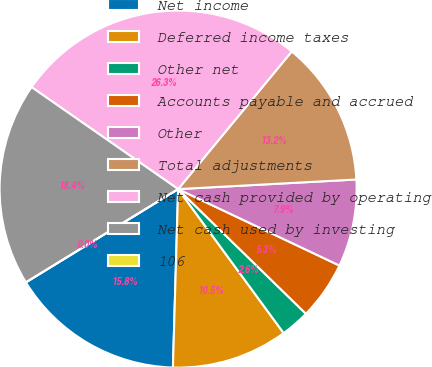Convert chart to OTSL. <chart><loc_0><loc_0><loc_500><loc_500><pie_chart><fcel>Net income<fcel>Deferred income taxes<fcel>Other net<fcel>Accounts payable and accrued<fcel>Other<fcel>Total adjustments<fcel>Net cash provided by operating<fcel>Net cash used by investing<fcel>106<nl><fcel>15.79%<fcel>10.53%<fcel>2.63%<fcel>5.26%<fcel>7.9%<fcel>13.16%<fcel>26.31%<fcel>18.42%<fcel>0.0%<nl></chart> 